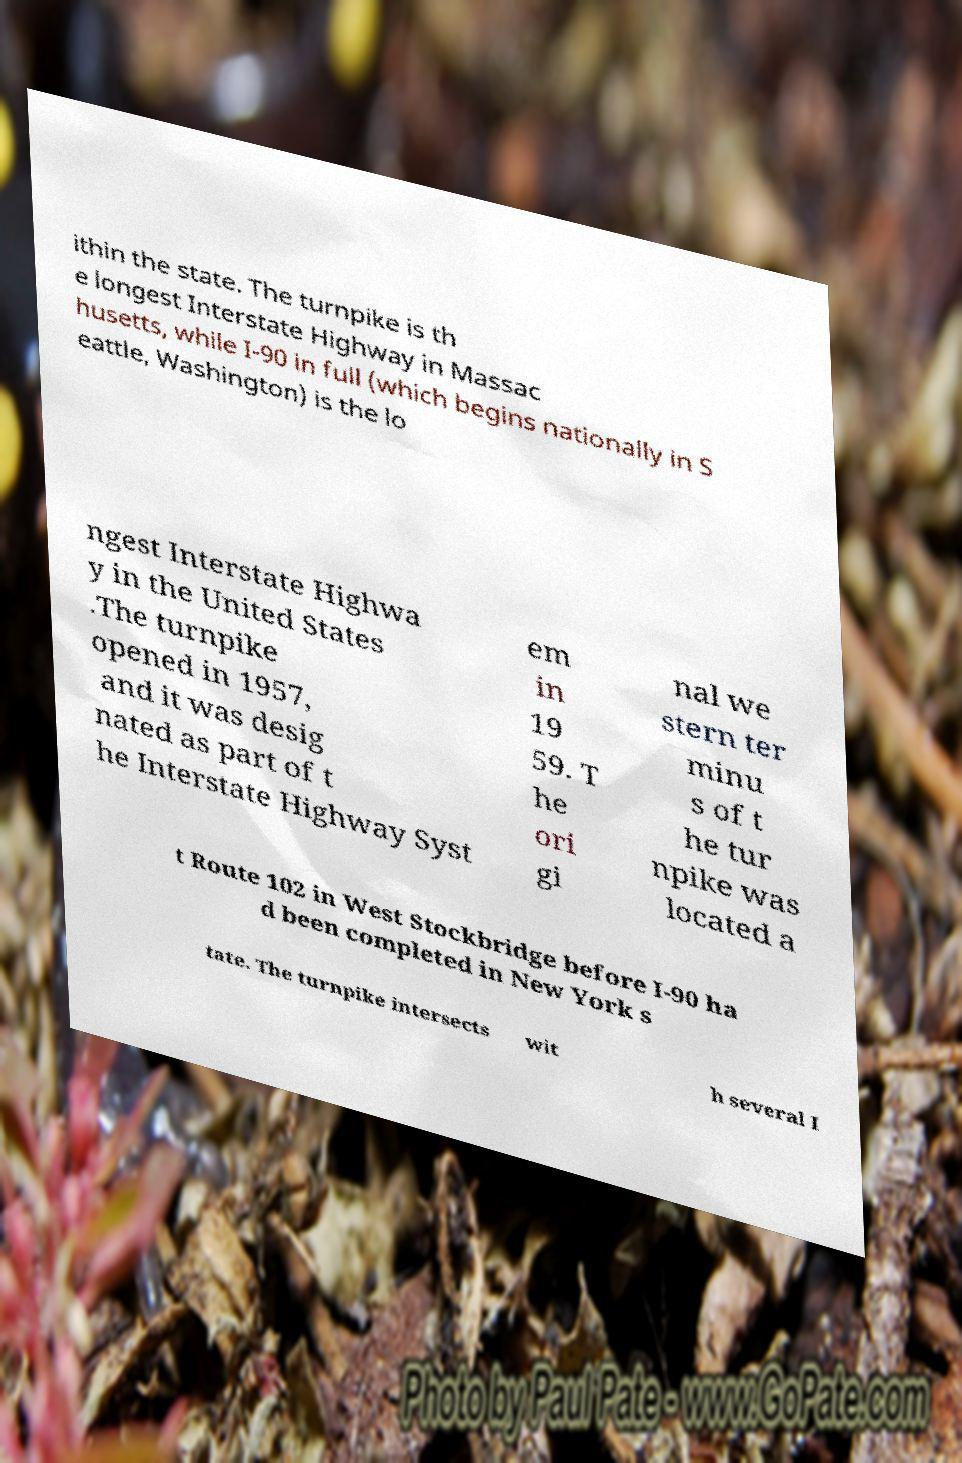Could you assist in decoding the text presented in this image and type it out clearly? ithin the state. The turnpike is th e longest Interstate Highway in Massac husetts, while I-90 in full (which begins nationally in S eattle, Washington) is the lo ngest Interstate Highwa y in the United States .The turnpike opened in 1957, and it was desig nated as part of t he Interstate Highway Syst em in 19 59. T he ori gi nal we stern ter minu s of t he tur npike was located a t Route 102 in West Stockbridge before I-90 ha d been completed in New York s tate. The turnpike intersects wit h several I 